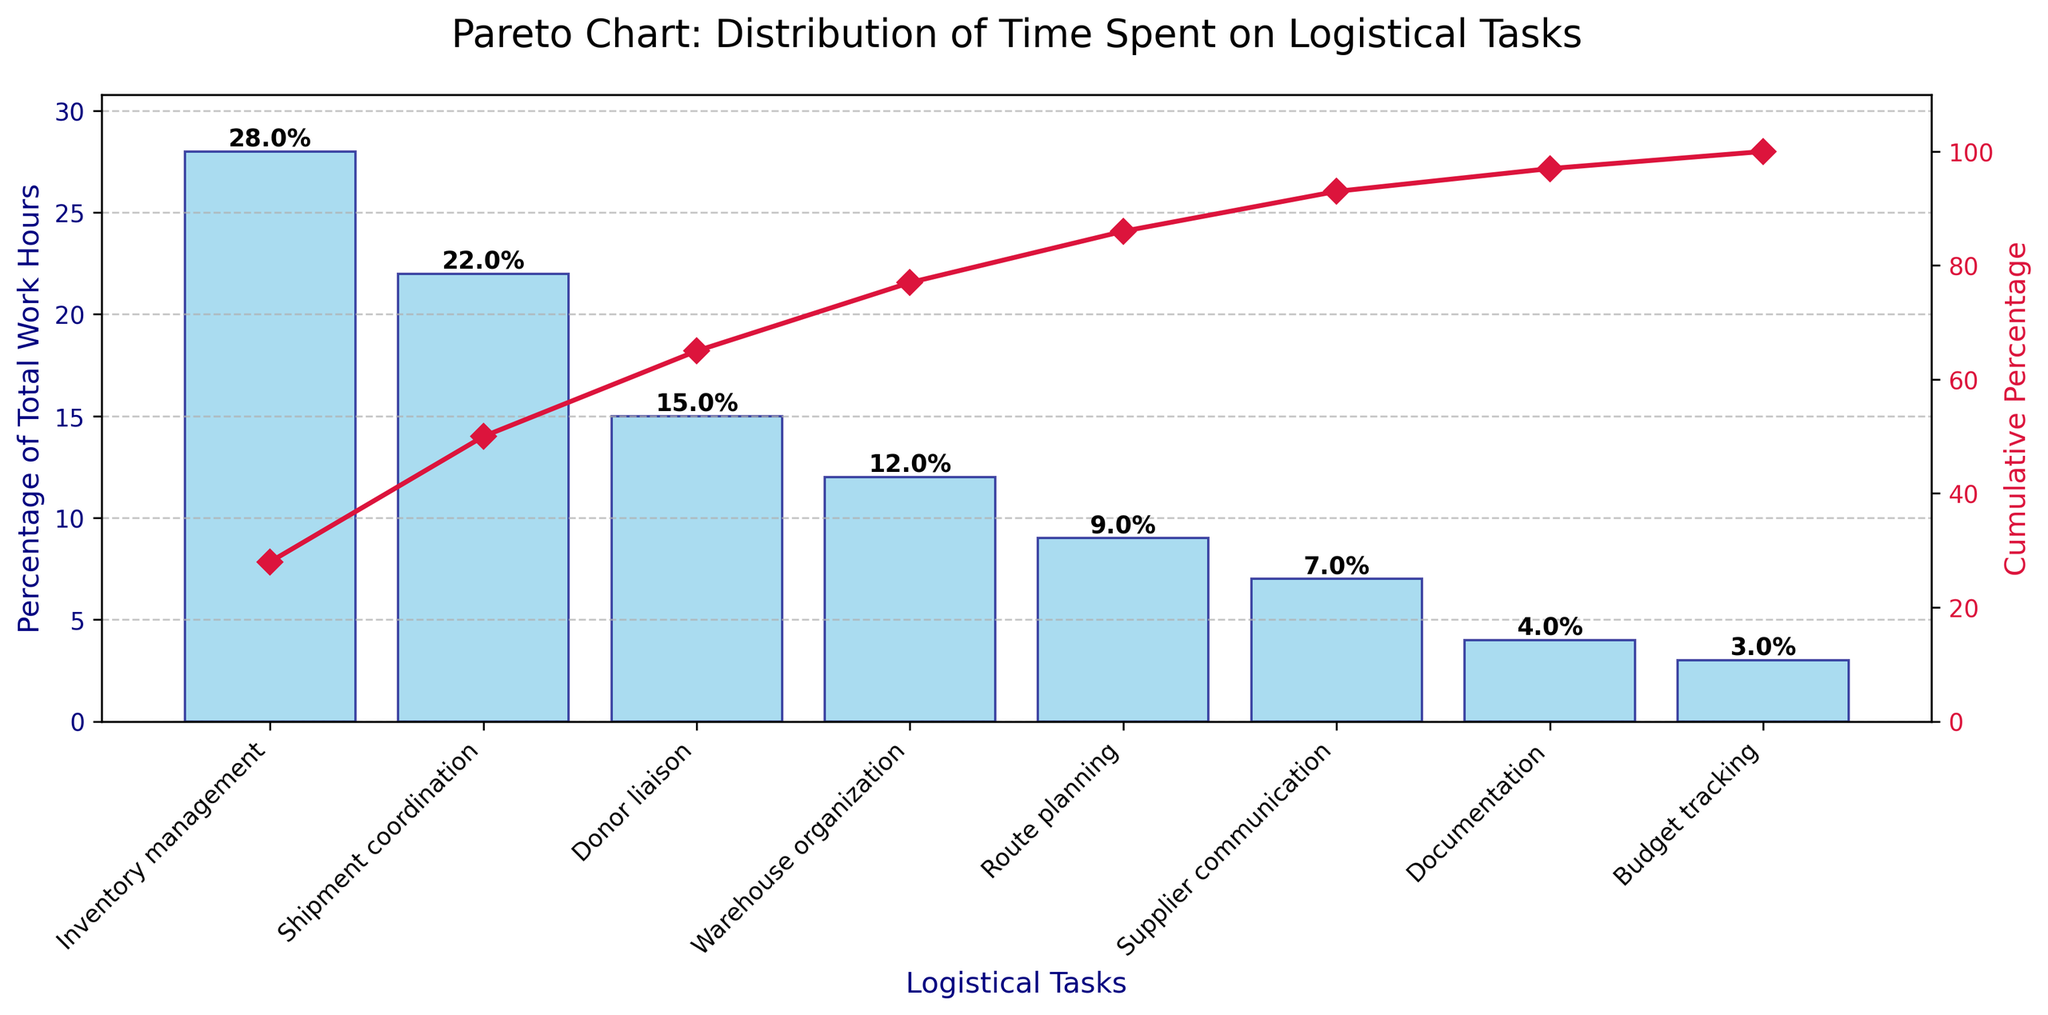Which task consumes the most work hours according to the chart? The task with the highest percentage bar in the chart consumes the most work hours. The highest bar corresponds to "Inventory management" with 28%.
Answer: Inventory management What is the cumulative percentage of time spent on the top three tasks? To get the cumulative percentage of the top three tasks, sum the individual percentages of those tasks: Inventory management (28%) + Shipment coordination (22%) + Donor liaison (15%). This equals 65%.
Answer: 65% How much more time is spent on Inventory management compared to Route planning? Subtract the percentage of time spent on Route planning (9%) from the percentage of time spent on Inventory management (28%): 28% - 9% = 19%.
Answer: 19% Which task has the lowest contribution to the total work hours? The task with the smallest percentage bar in the chart has the lowest contribution. This corresponds to "Budget tracking" with 3%.
Answer: Budget tracking What percentage of the total work hours is spent on tasks other than the top 2 tasks? First, calculate the percentage for the top two tasks: Inventory management (28%) and Shipment coordination (22%). Their sum is 50%. Then, subtract this from 100% to find the remaining percentage: 100% - 50% = 50%.
Answer: 50% At what point (in terms of tasks) does the cumulative percentage exceed 75%? Start by adding the contributions of tasks sequentially until the cumulative sum exceeds 75%. Inventory management (28%) + Shipment coordination (22%) + Donor liaison (15%) = 65%. Adding Warehouse organization (12%) brings the cumulative percentage to 77%, which exceeds 75%. Therefore, it surpasses 75% after adding Warehouse organization.
Answer: Warehouse organization Which tasks combined account for over half of the total work hours? Identify tasks whose combined percentages exceed 50%. Inventory management (28%) + Shipment coordination (22%) equals 50%. Thus, these two tasks together account for over half of the total work hours.
Answer: Inventory management and Shipment coordination What is the cumulative percentage after including Shipment coordination? The cumulative percentage is the sum of the percentage values up to and including Shipment coordination. Inventory management (28%) + Shipment coordination (22%) = 50%.
Answer: 50% Which task represents almost half the time spent compared to Shipment coordination? Calculate the percentage value that is roughly half of Shipment coordination (22%). This value is about 11%. Compare it with the percentages for other tasks; Route Planning is 9%, which is close but not half. Warehouse organization is 12%, which is more accurate.
Answer: Warehouse organization 